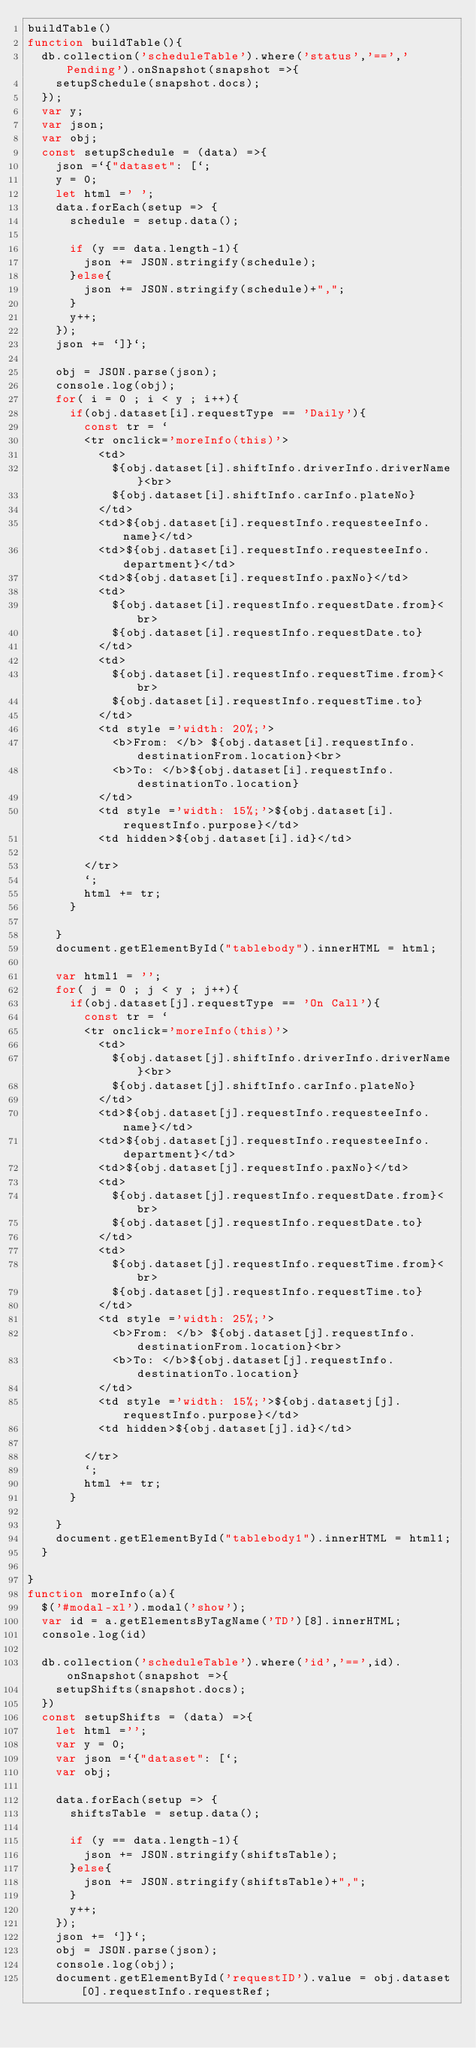Convert code to text. <code><loc_0><loc_0><loc_500><loc_500><_JavaScript_>buildTable()
function buildTable(){
  db.collection('scheduleTable').where('status','==','Pending').onSnapshot(snapshot =>{
    setupSchedule(snapshot.docs);
  });
  var y;
  var json;
  var obj;
  const setupSchedule = (data) =>{
    json =`{"dataset": [`;
    y = 0;
    let html =' ';
    data.forEach(setup => {
      schedule = setup.data();

      if (y == data.length-1){
        json += JSON.stringify(schedule);
      }else{
        json += JSON.stringify(schedule)+",";
      }
      y++;
    });
    json += `]}`;

    obj = JSON.parse(json);
    console.log(obj);
    for( i = 0 ; i < y ; i++){
      if(obj.dataset[i].requestType == 'Daily'){
        const tr = `
        <tr onclick='moreInfo(this)'>
          <td>
            ${obj.dataset[i].shiftInfo.driverInfo.driverName}<br>
            ${obj.dataset[i].shiftInfo.carInfo.plateNo}
          </td>
          <td>${obj.dataset[i].requestInfo.requesteeInfo.name}</td>
          <td>${obj.dataset[i].requestInfo.requesteeInfo.department}</td>
          <td>${obj.dataset[i].requestInfo.paxNo}</td>
          <td>
            ${obj.dataset[i].requestInfo.requestDate.from}<br>
            ${obj.dataset[i].requestInfo.requestDate.to}
          </td>
          <td>
            ${obj.dataset[i].requestInfo.requestTime.from}<br>
            ${obj.dataset[i].requestInfo.requestTime.to}
          </td>
          <td style ='width: 20%;'>
            <b>From: </b> ${obj.dataset[i].requestInfo.destinationFrom.location}<br>
            <b>To: </b>${obj.dataset[i].requestInfo.destinationTo.location}
          </td>
          <td style ='width: 15%;'>${obj.dataset[i].requestInfo.purpose}</td>
          <td hidden>${obj.dataset[i].id}</td>

        </tr>
        `;
        html += tr;
      }

    }
    document.getElementById("tablebody").innerHTML = html;

    var html1 = '';
    for( j = 0 ; j < y ; j++){
      if(obj.dataset[j].requestType == 'On Call'){
        const tr = `
        <tr onclick='moreInfo(this)'>
          <td>
            ${obj.dataset[j].shiftInfo.driverInfo.driverName}<br>
            ${obj.dataset[j].shiftInfo.carInfo.plateNo}
          </td>
          <td>${obj.dataset[j].requestInfo.requesteeInfo.name}</td>
          <td>${obj.dataset[j].requestInfo.requesteeInfo.department}</td>
          <td>${obj.dataset[j].requestInfo.paxNo}</td>
          <td>
            ${obj.dataset[j].requestInfo.requestDate.from}<br>
            ${obj.dataset[j].requestInfo.requestDate.to}
          </td>
          <td>
            ${obj.dataset[j].requestInfo.requestTime.from}<br>
            ${obj.dataset[j].requestInfo.requestTime.to}
          </td>
          <td style ='width: 25%;'>
            <b>From: </b> ${obj.dataset[j].requestInfo.destinationFrom.location}<br>
            <b>To: </b>${obj.dataset[j].requestInfo.destinationTo.location}
          </td>
          <td style ='width: 15%;'>${obj.datasetj[j].requestInfo.purpose}</td>
          <td hidden>${obj.dataset[j].id}</td>

        </tr>
        `;
        html += tr;
      }

    }
    document.getElementById("tablebody1").innerHTML = html1;
  }

}
function moreInfo(a){
  $('#modal-xl').modal('show');
  var id = a.getElementsByTagName('TD')[8].innerHTML;
  console.log(id)

  db.collection('scheduleTable').where('id','==',id).onSnapshot(snapshot =>{
    setupShifts(snapshot.docs);
  })
  const setupShifts = (data) =>{
    let html ='';
    var y = 0;
    var json =`{"dataset": [`;
    var obj;

    data.forEach(setup => {
      shiftsTable = setup.data();

      if (y == data.length-1){
        json += JSON.stringify(shiftsTable);
      }else{
        json += JSON.stringify(shiftsTable)+",";
      }
      y++;
    });
    json += `]}`;
    obj = JSON.parse(json);
    console.log(obj);
    document.getElementById('requestID').value = obj.dataset[0].requestInfo.requestRef;</code> 